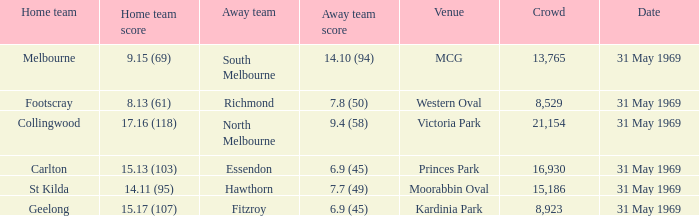Who was the opposing team in the game where the home team scored 15.17 (107)? Fitzroy. 